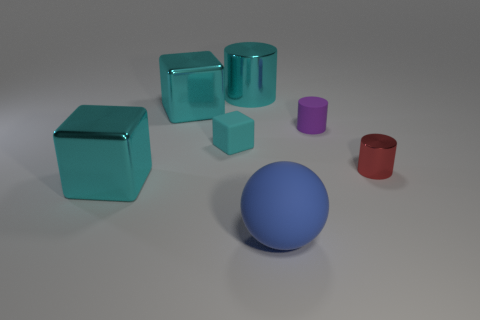Subtract all cyan blocks. How many were subtracted if there are1cyan blocks left? 2 Add 2 shiny cylinders. How many objects exist? 9 Subtract all balls. How many objects are left? 6 Subtract 0 brown spheres. How many objects are left? 7 Subtract all tiny cubes. Subtract all blue spheres. How many objects are left? 5 Add 4 big cyan shiny objects. How many big cyan shiny objects are left? 7 Add 7 large red shiny things. How many large red shiny things exist? 7 